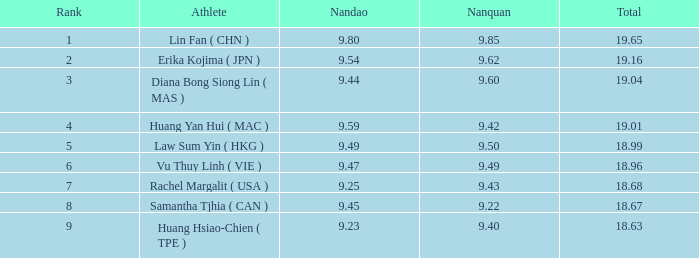68? None. 